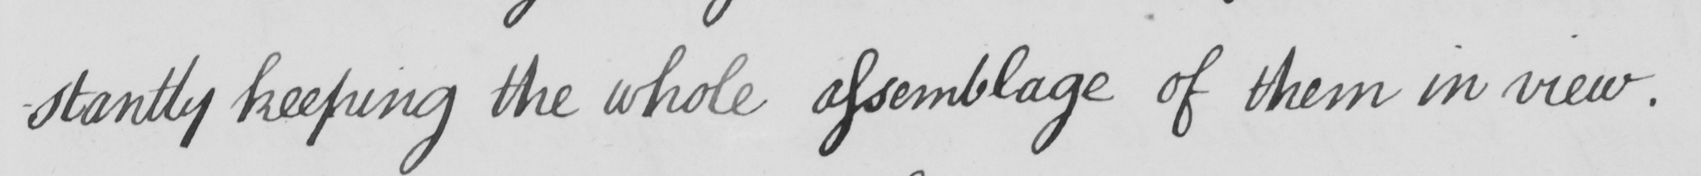What is written in this line of handwriting? -stantly keeping the whole assemblage of them in view . 